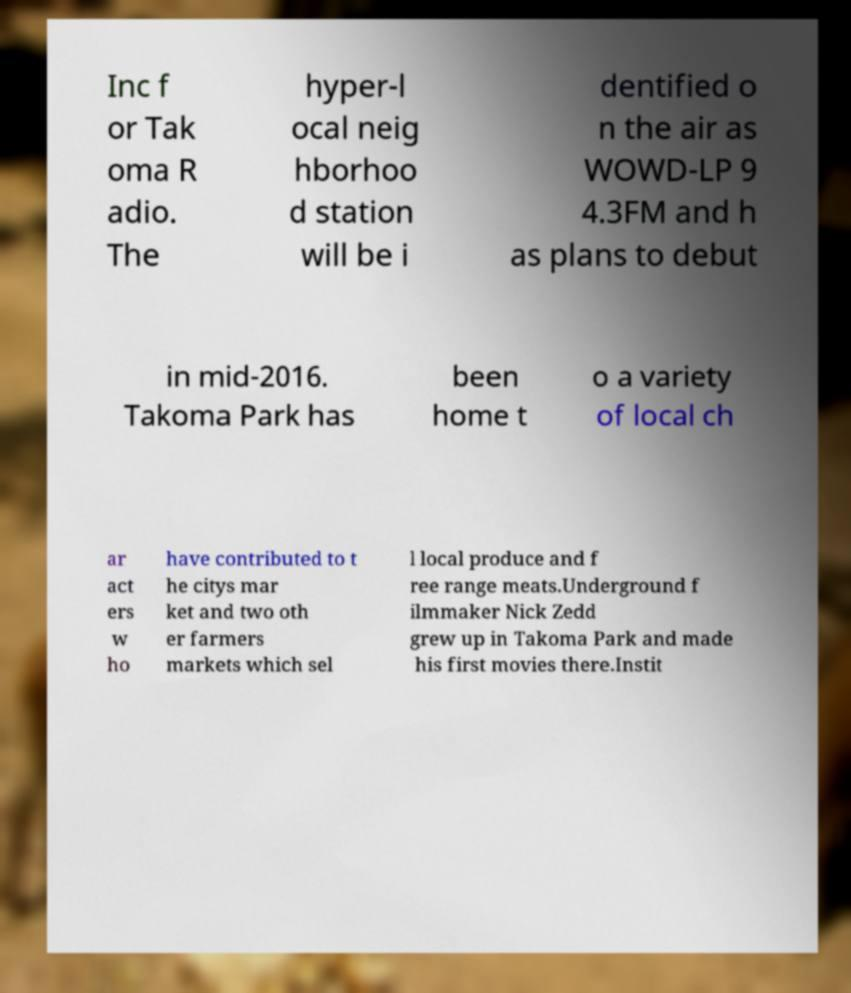Can you read and provide the text displayed in the image?This photo seems to have some interesting text. Can you extract and type it out for me? Inc f or Tak oma R adio. The hyper-l ocal neig hborhoo d station will be i dentified o n the air as WOWD-LP 9 4.3FM and h as plans to debut in mid-2016. Takoma Park has been home t o a variety of local ch ar act ers w ho have contributed to t he citys mar ket and two oth er farmers markets which sel l local produce and f ree range meats.Underground f ilmmaker Nick Zedd grew up in Takoma Park and made his first movies there.Instit 